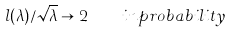Convert formula to latex. <formula><loc_0><loc_0><loc_500><loc_500>l ( \lambda ) / \sqrt { \lambda } \to 2 \quad i n p r o b a b i l i t y</formula> 